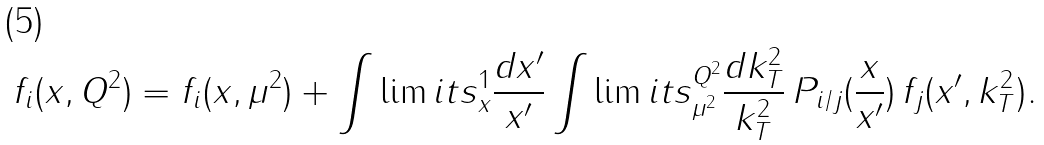Convert formula to latex. <formula><loc_0><loc_0><loc_500><loc_500>f _ { i } ( x , Q ^ { 2 } ) & = f _ { i } ( x , \mu ^ { 2 } ) + \int \lim i t s _ { x } ^ { 1 } \frac { d x ^ { \prime } } { x ^ { \prime } } \int \lim i t s _ { \mu ^ { 2 } } ^ { Q ^ { 2 } } \frac { d k _ { T } ^ { 2 } } { k _ { T } ^ { 2 } } \, P _ { i / j } ( \frac { x } { x ^ { \prime } } ) \, f _ { j } ( x ^ { \prime } , k _ { T } ^ { 2 } ) .</formula> 